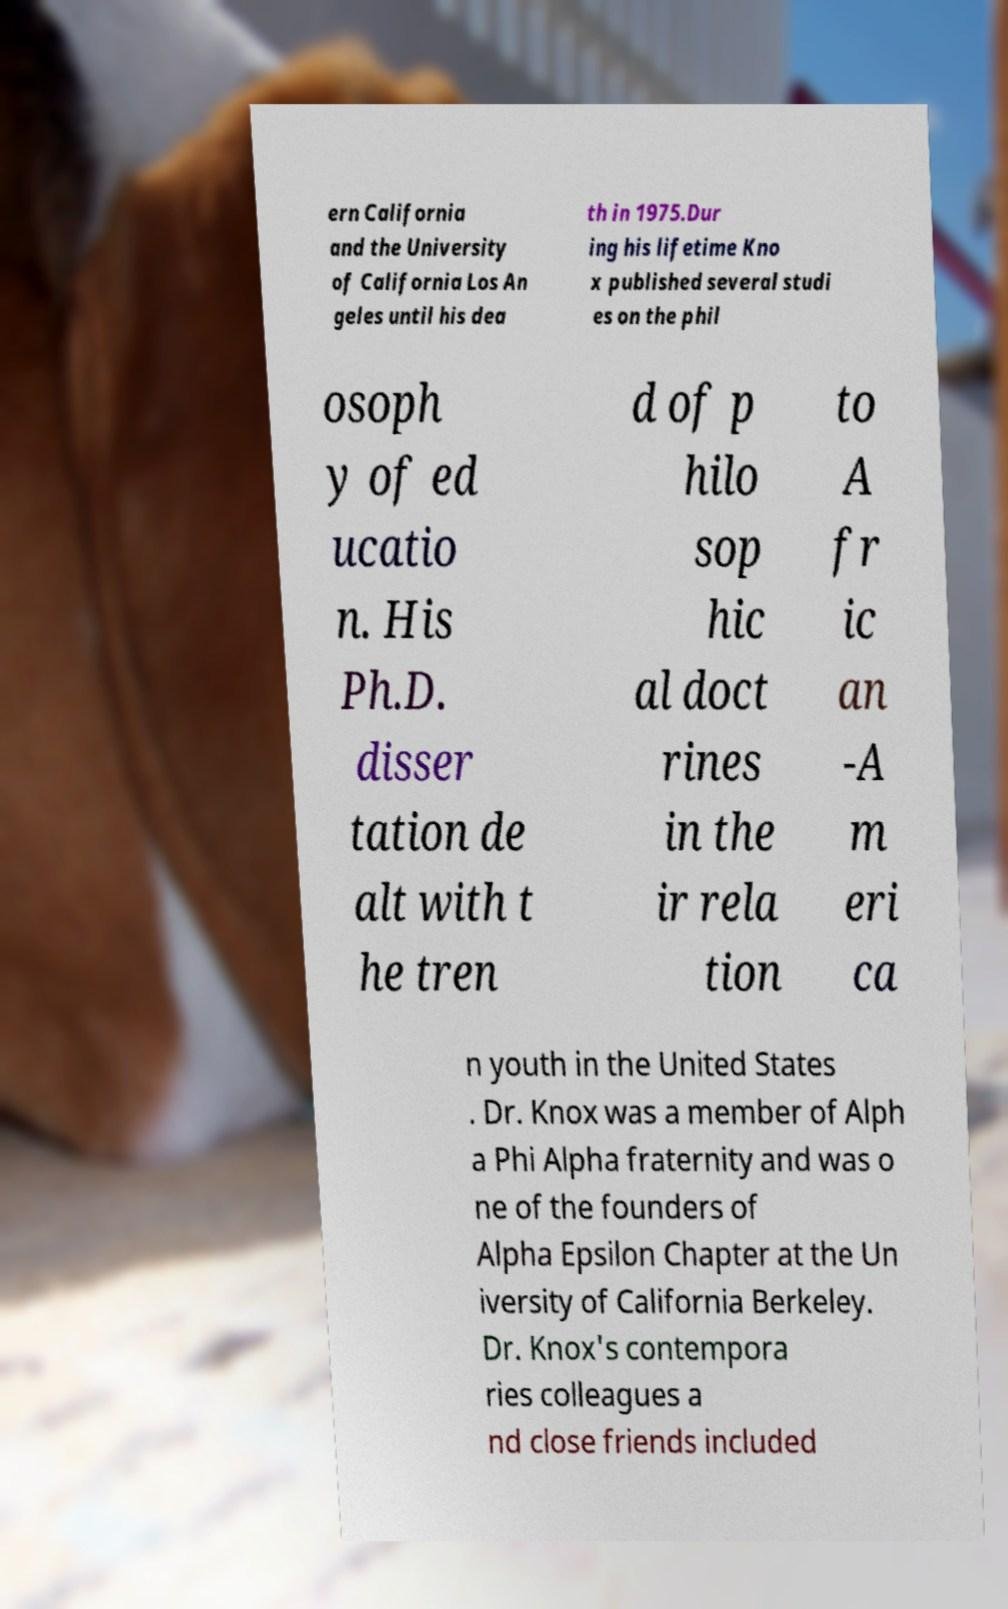For documentation purposes, I need the text within this image transcribed. Could you provide that? ern California and the University of California Los An geles until his dea th in 1975.Dur ing his lifetime Kno x published several studi es on the phil osoph y of ed ucatio n. His Ph.D. disser tation de alt with t he tren d of p hilo sop hic al doct rines in the ir rela tion to A fr ic an -A m eri ca n youth in the United States . Dr. Knox was a member of Alph a Phi Alpha fraternity and was o ne of the founders of Alpha Epsilon Chapter at the Un iversity of California Berkeley. Dr. Knox's contempora ries colleagues a nd close friends included 